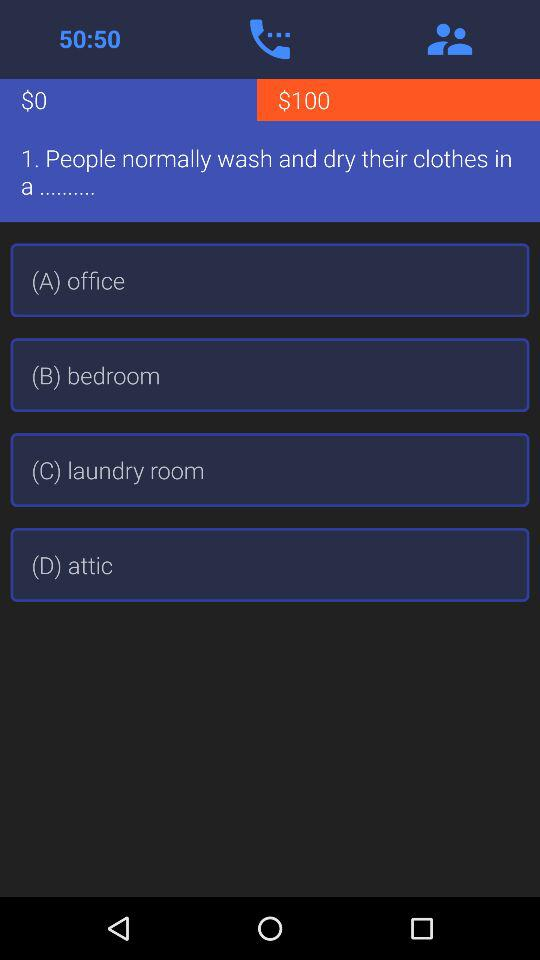Which option is not a place to wash clothes?
Answer the question using a single word or phrase. Attic 